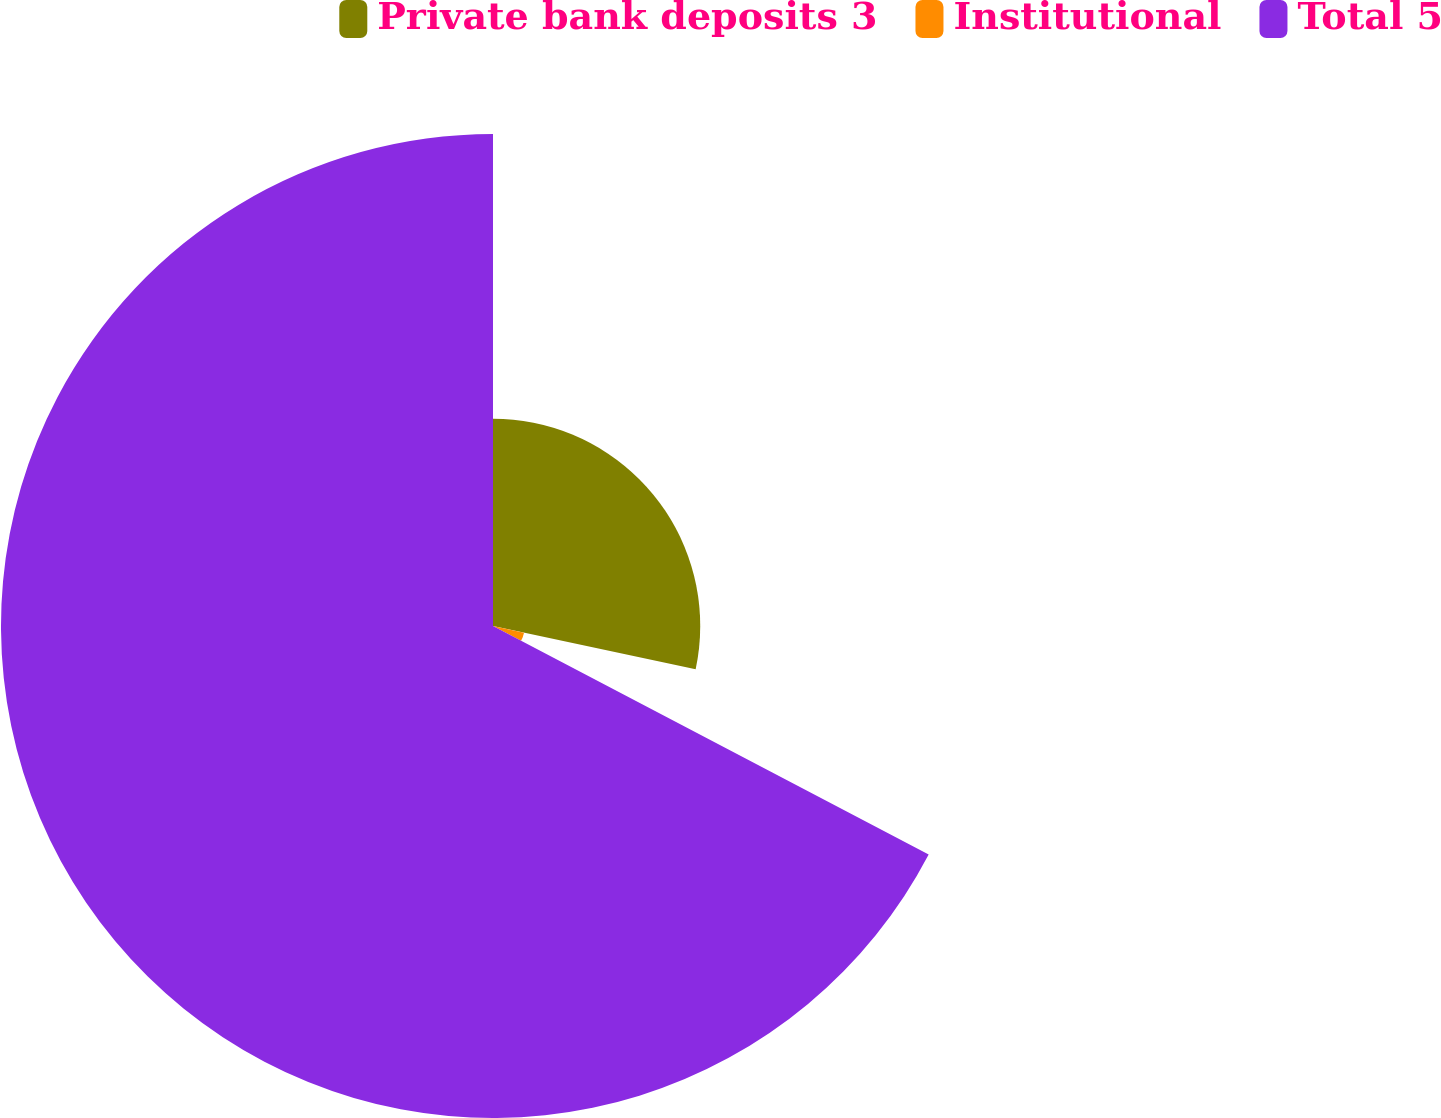<chart> <loc_0><loc_0><loc_500><loc_500><pie_chart><fcel>Private bank deposits 3<fcel>Institutional<fcel>Total 5<nl><fcel>28.35%<fcel>4.34%<fcel>67.31%<nl></chart> 